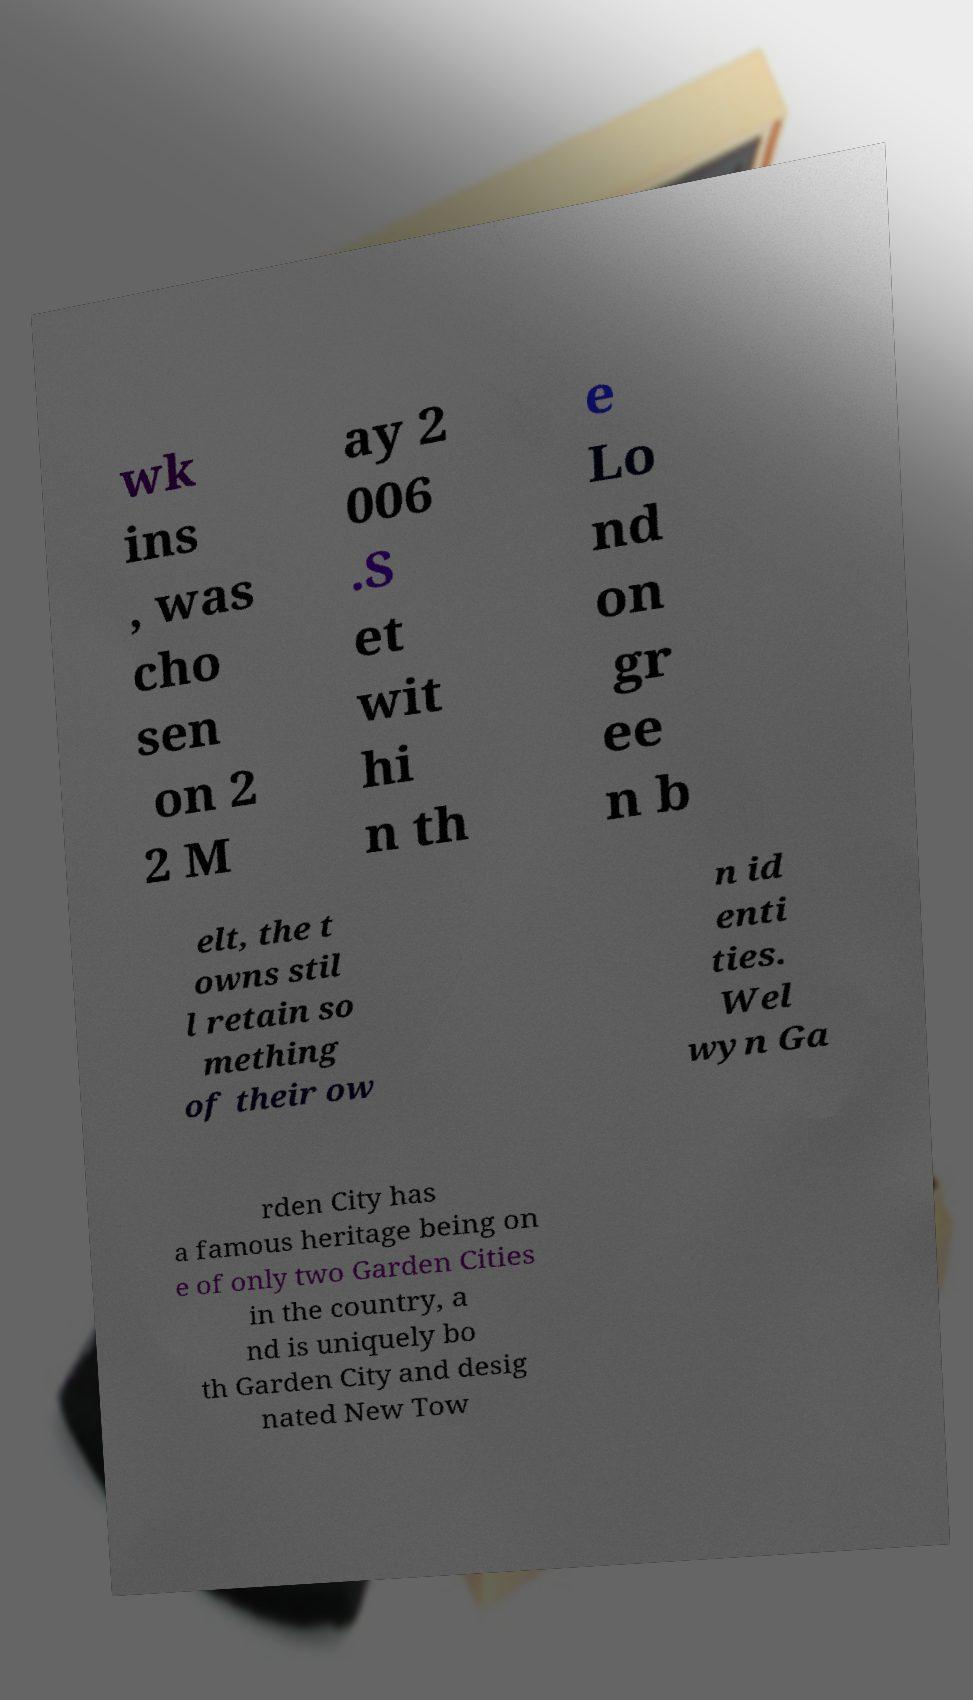Please read and relay the text visible in this image. What does it say? wk ins , was cho sen on 2 2 M ay 2 006 .S et wit hi n th e Lo nd on gr ee n b elt, the t owns stil l retain so mething of their ow n id enti ties. Wel wyn Ga rden City has a famous heritage being on e of only two Garden Cities in the country, a nd is uniquely bo th Garden City and desig nated New Tow 